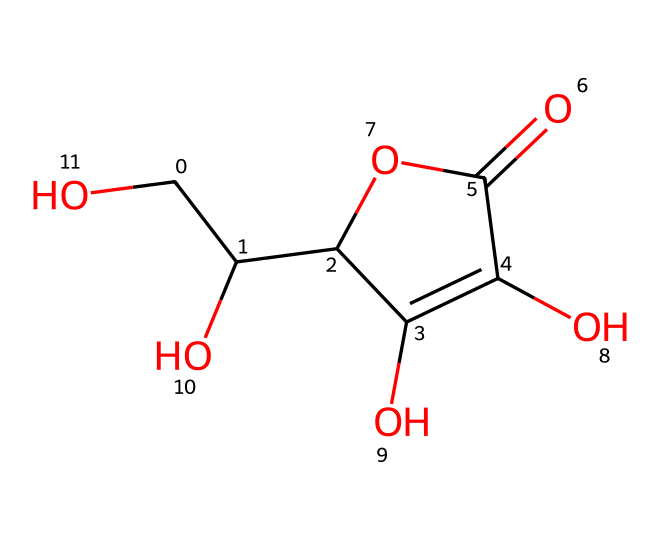What is the molecular formula of ascorbic acid? To find the molecular formula, we count the numbers of each type of atom present in the SMILES representation. The structure indicates there are 6 carbon atoms, 8 hydrogen atoms, and 6 oxygen atoms. Hence, the molecular formula is C6H8O6.
Answer: C6H8O6 How many hydroxyl groups (-OH) are present in ascorbic acid? In the SMILES representation, we can identify hydroxyl groups by looking for the -OH functional groups attached to carbon atoms. There are four distinct -OH groups, evident in the chemical structure.
Answer: 4 What type of chemical is ascorbic acid classified as? Ascorbic acid is classified as a vitamin and also as an antioxidant. Its structure shows multiple hydroxyl and carbonyl functional groups that contribute to its ability to donate electrons and scavenge free radicals.
Answer: antioxidant What is the degree of saturation in ascorbic acid? Degree of saturation indicates the number of double bonds present in the molecule. By analyzing the structure derived from the SMILES, there are two double bonds, which means it has a degree of saturation of 2.
Answer: 2 Which functional group is primarily responsible for ascorbic acid's antioxidant properties? The antioxidant properties primarily arise from the presence of hydroxyl (-OH) groups that can donate electrons, thus neutralizing free radicals. This donation ability is typically attributed to these functional groups.
Answer: hydroxyl What cyclic structure is present in ascorbic acid? The presence of a ring in the structure can be determined by the notation in the SMILES. Ascorbic acid includes a six-membered ring known as a lactone formed by the carbons and oxygens, indicated by the cyclic notation.
Answer: lactone 